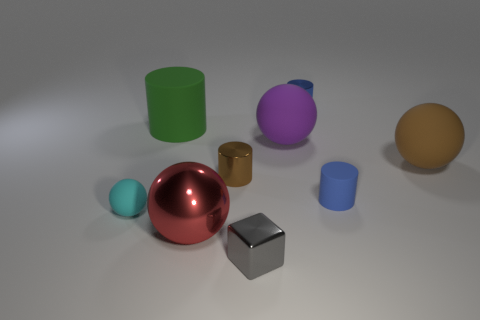Add 1 big red things. How many objects exist? 10 Subtract all matte spheres. How many spheres are left? 1 Subtract all cubes. How many objects are left? 8 Add 8 small rubber cylinders. How many small rubber cylinders are left? 9 Add 6 big green rubber spheres. How many big green rubber spheres exist? 6 Subtract all cyan balls. How many balls are left? 3 Subtract 0 yellow spheres. How many objects are left? 9 Subtract 4 spheres. How many spheres are left? 0 Subtract all cyan blocks. Subtract all yellow cylinders. How many blocks are left? 1 Subtract all purple cubes. How many brown cylinders are left? 1 